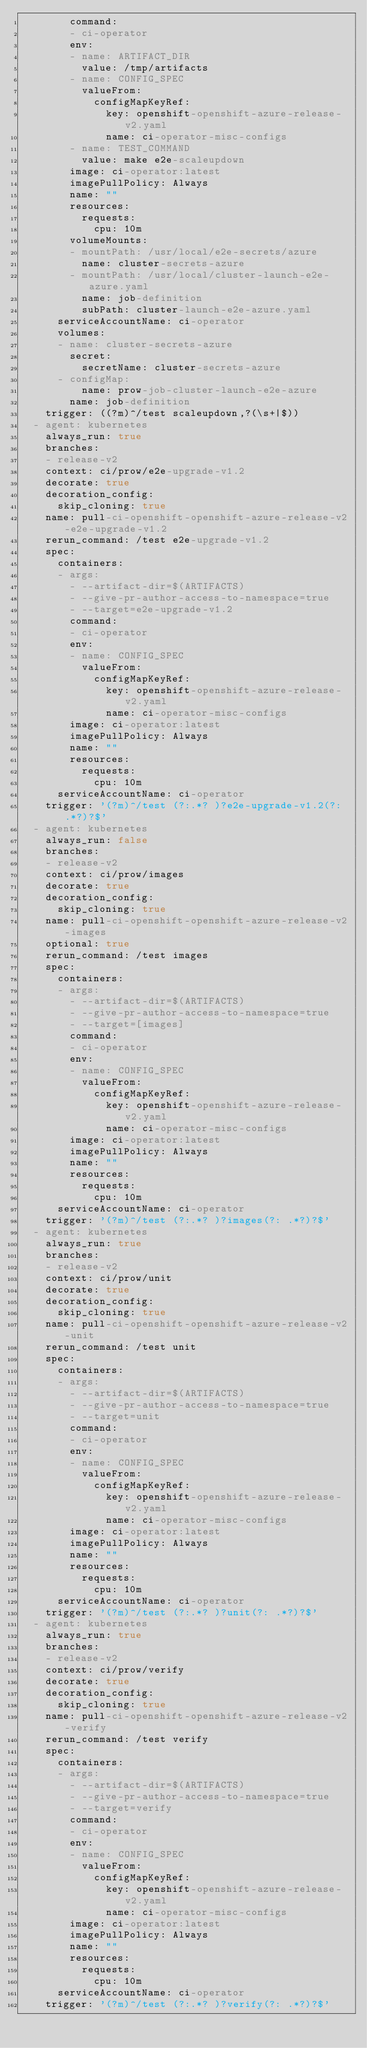Convert code to text. <code><loc_0><loc_0><loc_500><loc_500><_YAML_>        command:
        - ci-operator
        env:
        - name: ARTIFACT_DIR
          value: /tmp/artifacts
        - name: CONFIG_SPEC
          valueFrom:
            configMapKeyRef:
              key: openshift-openshift-azure-release-v2.yaml
              name: ci-operator-misc-configs
        - name: TEST_COMMAND
          value: make e2e-scaleupdown
        image: ci-operator:latest
        imagePullPolicy: Always
        name: ""
        resources:
          requests:
            cpu: 10m
        volumeMounts:
        - mountPath: /usr/local/e2e-secrets/azure
          name: cluster-secrets-azure
        - mountPath: /usr/local/cluster-launch-e2e-azure.yaml
          name: job-definition
          subPath: cluster-launch-e2e-azure.yaml
      serviceAccountName: ci-operator
      volumes:
      - name: cluster-secrets-azure
        secret:
          secretName: cluster-secrets-azure
      - configMap:
          name: prow-job-cluster-launch-e2e-azure
        name: job-definition
    trigger: ((?m)^/test scaleupdown,?(\s+|$))
  - agent: kubernetes
    always_run: true
    branches:
    - release-v2
    context: ci/prow/e2e-upgrade-v1.2
    decorate: true
    decoration_config:
      skip_cloning: true
    name: pull-ci-openshift-openshift-azure-release-v2-e2e-upgrade-v1.2
    rerun_command: /test e2e-upgrade-v1.2
    spec:
      containers:
      - args:
        - --artifact-dir=$(ARTIFACTS)
        - --give-pr-author-access-to-namespace=true
        - --target=e2e-upgrade-v1.2
        command:
        - ci-operator
        env:
        - name: CONFIG_SPEC
          valueFrom:
            configMapKeyRef:
              key: openshift-openshift-azure-release-v2.yaml
              name: ci-operator-misc-configs
        image: ci-operator:latest
        imagePullPolicy: Always
        name: ""
        resources:
          requests:
            cpu: 10m
      serviceAccountName: ci-operator
    trigger: '(?m)^/test (?:.*? )?e2e-upgrade-v1.2(?: .*?)?$'
  - agent: kubernetes
    always_run: false
    branches:
    - release-v2
    context: ci/prow/images
    decorate: true
    decoration_config:
      skip_cloning: true
    name: pull-ci-openshift-openshift-azure-release-v2-images
    optional: true
    rerun_command: /test images
    spec:
      containers:
      - args:
        - --artifact-dir=$(ARTIFACTS)
        - --give-pr-author-access-to-namespace=true
        - --target=[images]
        command:
        - ci-operator
        env:
        - name: CONFIG_SPEC
          valueFrom:
            configMapKeyRef:
              key: openshift-openshift-azure-release-v2.yaml
              name: ci-operator-misc-configs
        image: ci-operator:latest
        imagePullPolicy: Always
        name: ""
        resources:
          requests:
            cpu: 10m
      serviceAccountName: ci-operator
    trigger: '(?m)^/test (?:.*? )?images(?: .*?)?$'
  - agent: kubernetes
    always_run: true
    branches:
    - release-v2
    context: ci/prow/unit
    decorate: true
    decoration_config:
      skip_cloning: true
    name: pull-ci-openshift-openshift-azure-release-v2-unit
    rerun_command: /test unit
    spec:
      containers:
      - args:
        - --artifact-dir=$(ARTIFACTS)
        - --give-pr-author-access-to-namespace=true
        - --target=unit
        command:
        - ci-operator
        env:
        - name: CONFIG_SPEC
          valueFrom:
            configMapKeyRef:
              key: openshift-openshift-azure-release-v2.yaml
              name: ci-operator-misc-configs
        image: ci-operator:latest
        imagePullPolicy: Always
        name: ""
        resources:
          requests:
            cpu: 10m
      serviceAccountName: ci-operator
    trigger: '(?m)^/test (?:.*? )?unit(?: .*?)?$'
  - agent: kubernetes
    always_run: true
    branches:
    - release-v2
    context: ci/prow/verify
    decorate: true
    decoration_config:
      skip_cloning: true
    name: pull-ci-openshift-openshift-azure-release-v2-verify
    rerun_command: /test verify
    spec:
      containers:
      - args:
        - --artifact-dir=$(ARTIFACTS)
        - --give-pr-author-access-to-namespace=true
        - --target=verify
        command:
        - ci-operator
        env:
        - name: CONFIG_SPEC
          valueFrom:
            configMapKeyRef:
              key: openshift-openshift-azure-release-v2.yaml
              name: ci-operator-misc-configs
        image: ci-operator:latest
        imagePullPolicy: Always
        name: ""
        resources:
          requests:
            cpu: 10m
      serviceAccountName: ci-operator
    trigger: '(?m)^/test (?:.*? )?verify(?: .*?)?$'
</code> 